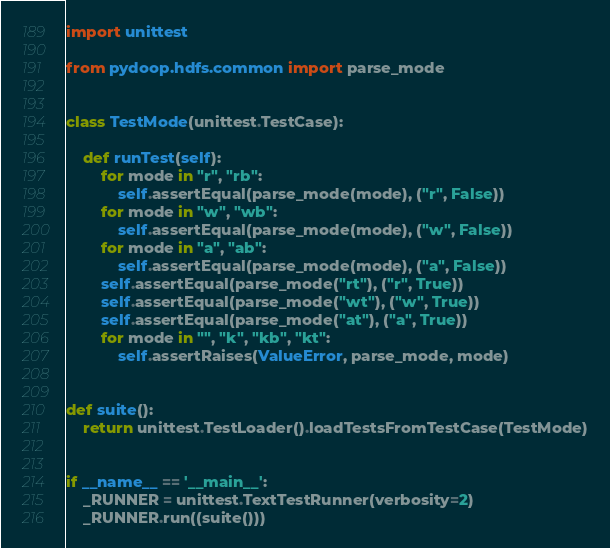<code> <loc_0><loc_0><loc_500><loc_500><_Python_>
import unittest

from pydoop.hdfs.common import parse_mode


class TestMode(unittest.TestCase):

    def runTest(self):
        for mode in "r", "rb":
            self.assertEqual(parse_mode(mode), ("r", False))
        for mode in "w", "wb":
            self.assertEqual(parse_mode(mode), ("w", False))
        for mode in "a", "ab":
            self.assertEqual(parse_mode(mode), ("a", False))
        self.assertEqual(parse_mode("rt"), ("r", True))
        self.assertEqual(parse_mode("wt"), ("w", True))
        self.assertEqual(parse_mode("at"), ("a", True))
        for mode in "", "k", "kb", "kt":
            self.assertRaises(ValueError, parse_mode, mode)


def suite():
    return unittest.TestLoader().loadTestsFromTestCase(TestMode)


if __name__ == '__main__':
    _RUNNER = unittest.TextTestRunner(verbosity=2)
    _RUNNER.run((suite()))
</code> 